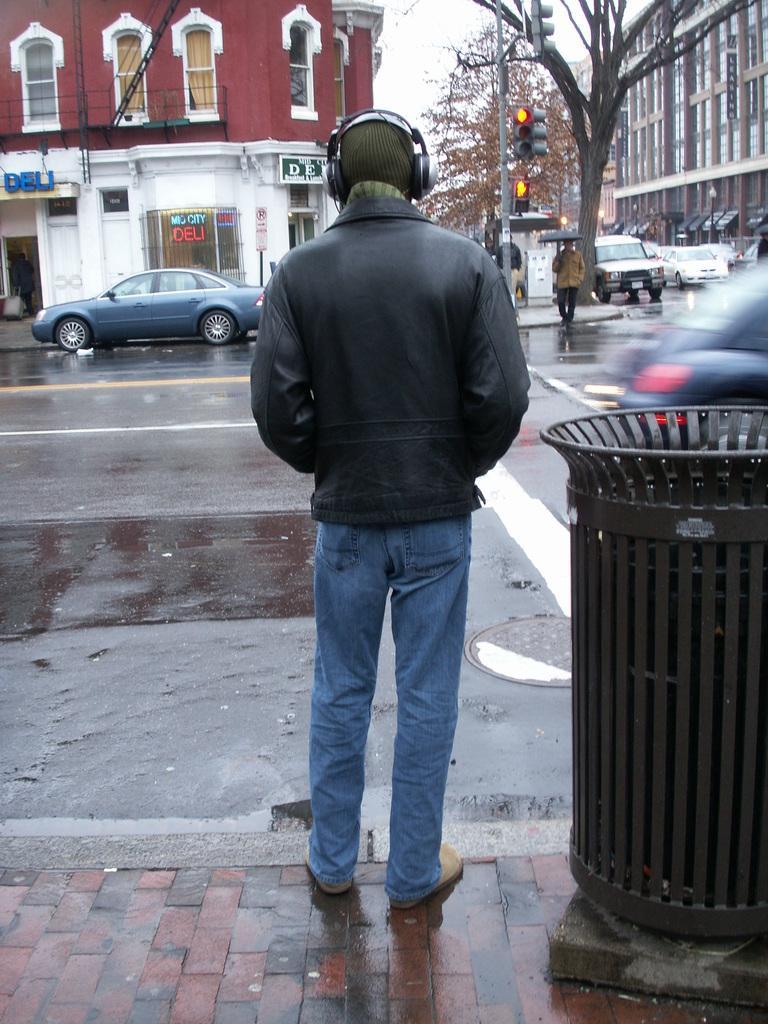Could you give a brief overview of what you see in this image? In this image, there are a few people and vehicles. We can see the ground. There are a few buildings. Among them, we can see a building with some text. We can also see a board with some text. We can see a pole with traffic lights. We can also see a tree and the sky. We can see a black colored container at the bottom right. 